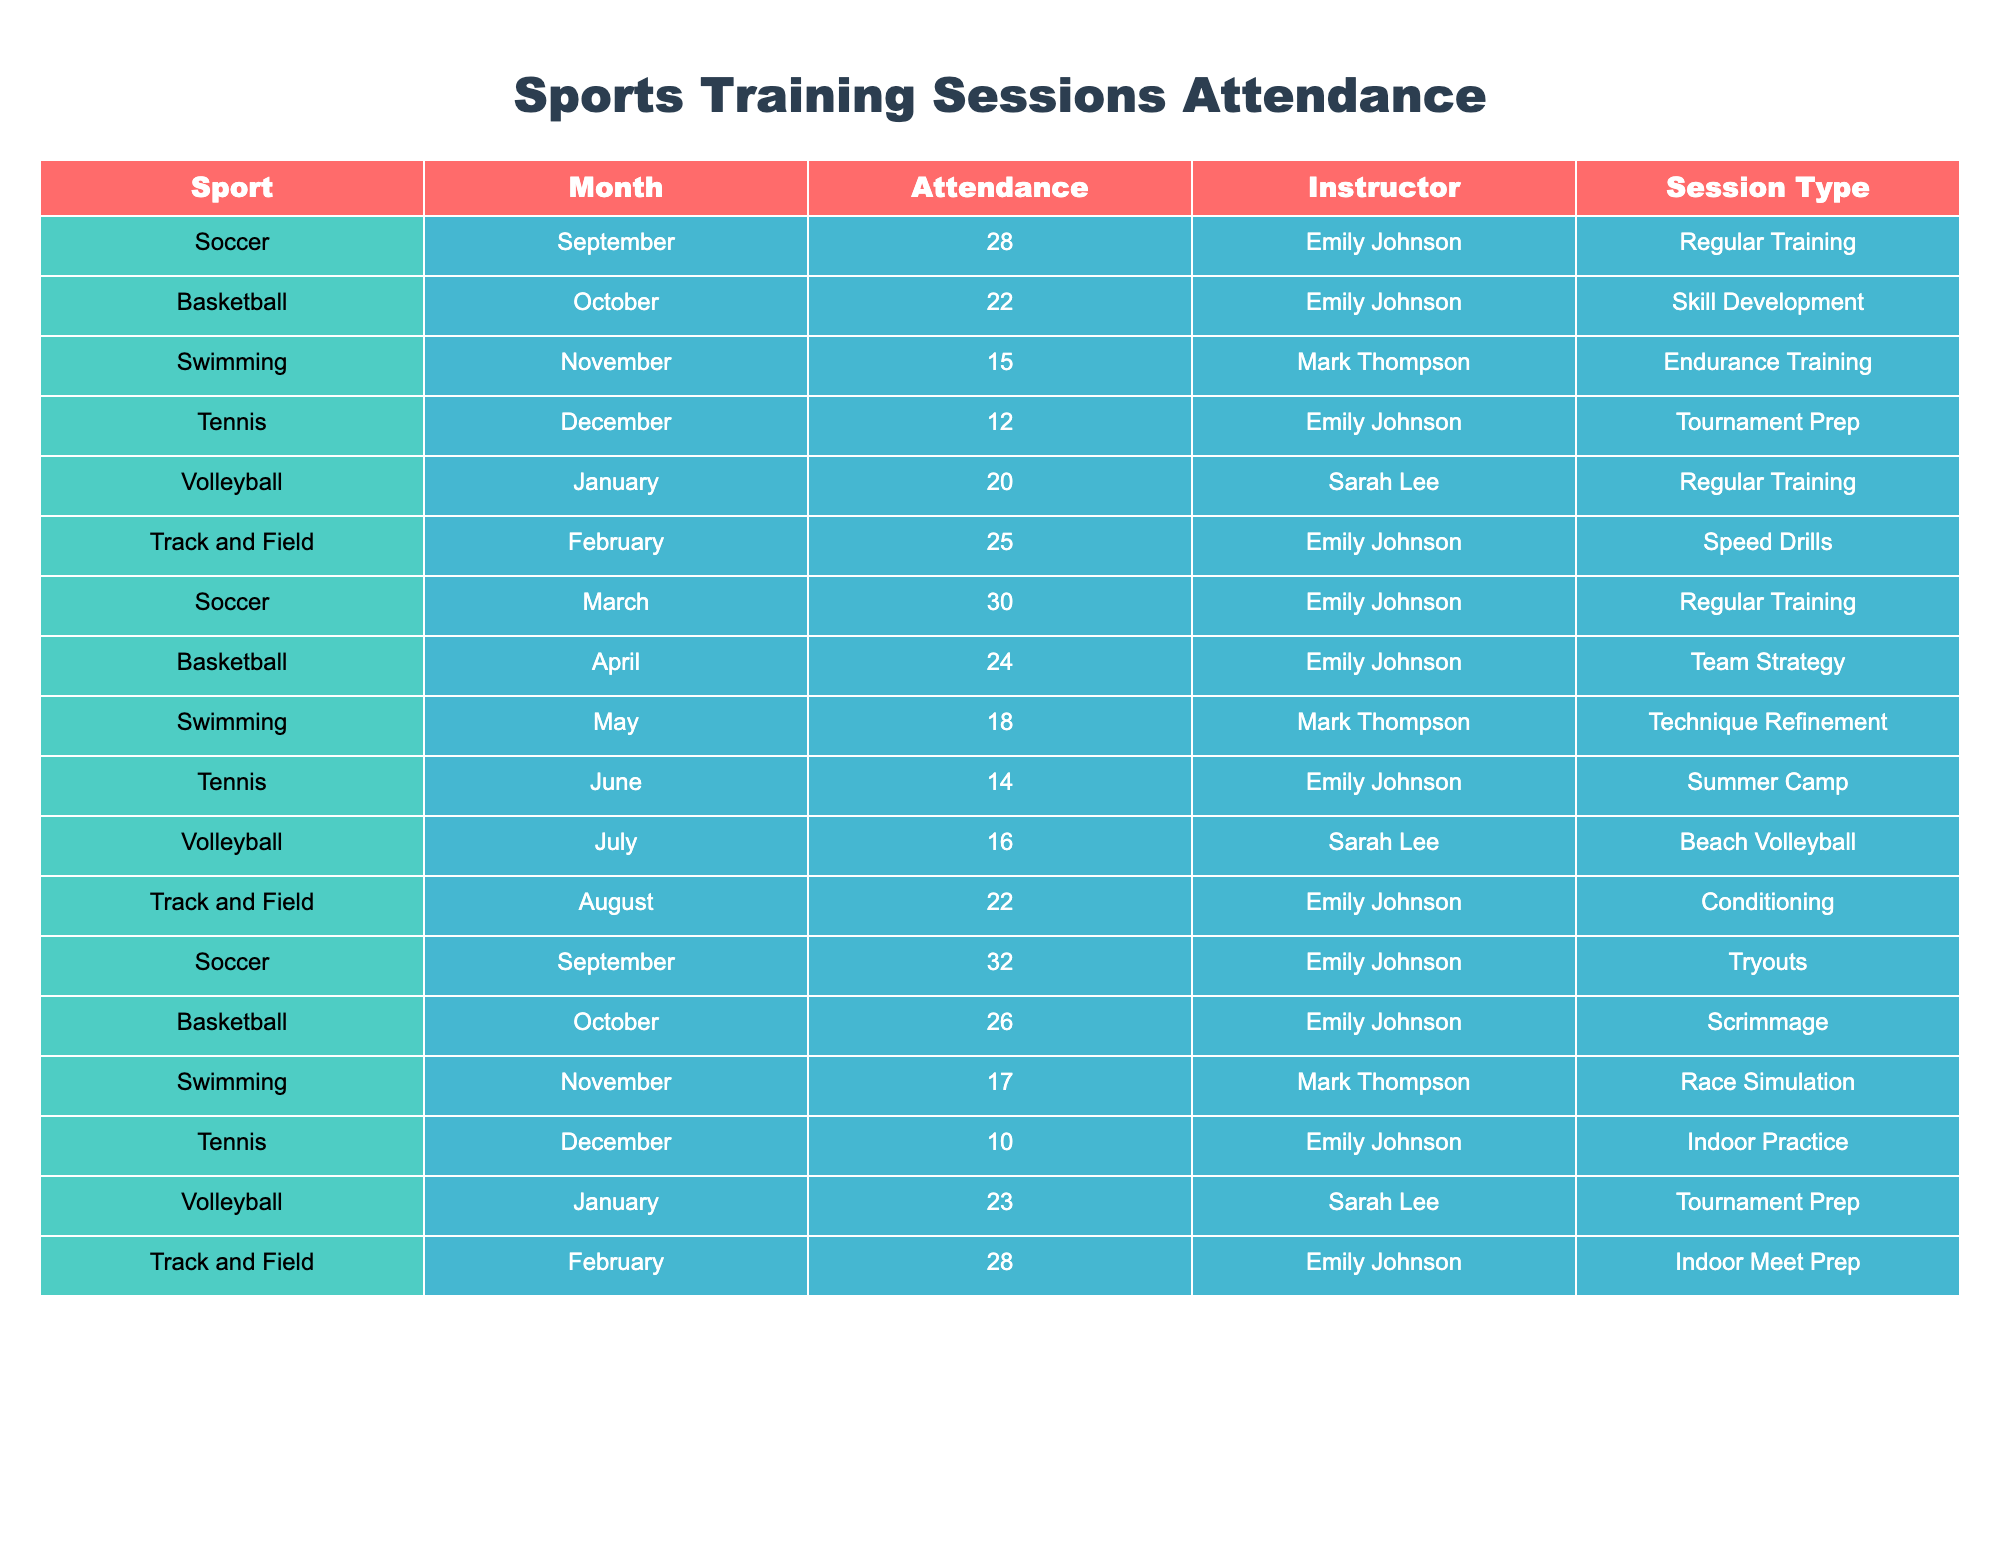What sport had the highest attendance in March? In March, the attendance for soccer sessions was recorded as 30, which is the highest when compared to the attendance of other sports in that month.
Answer: Soccer How many attendance records were there for basketball throughout the academic year? Basketball had attendance records in October (22), April (24), and an additional record in October (26) which makes a total of 3 records.
Answer: 3 What was the average attendance for the track and field sessions for the entire year? The track and field sessions had attendances of 25 (February), 28 (August), and the corresponding attendances for each month total up to 53. There are 2 records, so the average is 53/2 = 26.5.
Answer: 26.5 Did swimming attendance ever exceed 20 participants? Swimming attendance records show figures of 15, 18, and 17, which never exceed 20 participants, confirming the answer is no.
Answer: No Which instructor had the least attendance in their sport for December? In December, tennis had the least attendance of 10 participants, taught by Emily Johnson, while all other sports had higher numbers.
Answer: Tennis Which month had the highest attendance in volleyball sessions? The attendance record for volleyball in January is 23, which was the highest recorded attendance for volleyball compared to 20 in September and 16 in July.
Answer: January What is the total attendance for soccer sessions throughout the academic year? Soccer had attendances of 28, 30, and 32 across the months, totaling 28 + 30 + 32 = 90.
Answer: 90 Is there any sport that had a consistent increase in attendance month over month? By examining the records, volleyball shows an increase from 20 in September to 23 in January, indicating an upward trend in attendance.
Answer: Yes What was the attendance for skill development sessions led by Emily Johnson? The sports in focus show that Emily Johnson led basketball sessions for skill development in October, where the attendance was 22.
Answer: 22 What sport had the lowest overall attendance throughout the year? Among all sports, tennis recorded the lowest attendance of 10 in December when compared with the other sports listed.
Answer: Tennis 